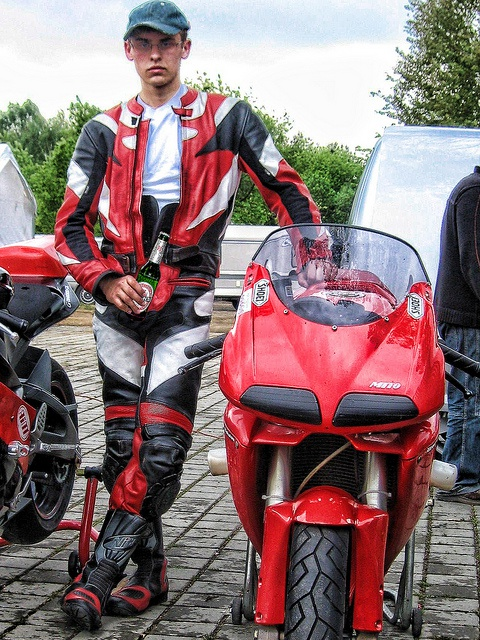Describe the objects in this image and their specific colors. I can see motorcycle in white, black, brown, salmon, and red tones, people in white, black, lavender, gray, and brown tones, motorcycle in white, black, gray, brown, and darkgray tones, car in white, lightblue, and darkgray tones, and people in white, black, gray, and blue tones in this image. 